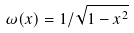<formula> <loc_0><loc_0><loc_500><loc_500>\omega ( x ) = 1 / \sqrt { 1 - x ^ { 2 } }</formula> 